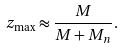<formula> <loc_0><loc_0><loc_500><loc_500>z _ { \max } \approx \frac { M } { M + M _ { n } } .</formula> 